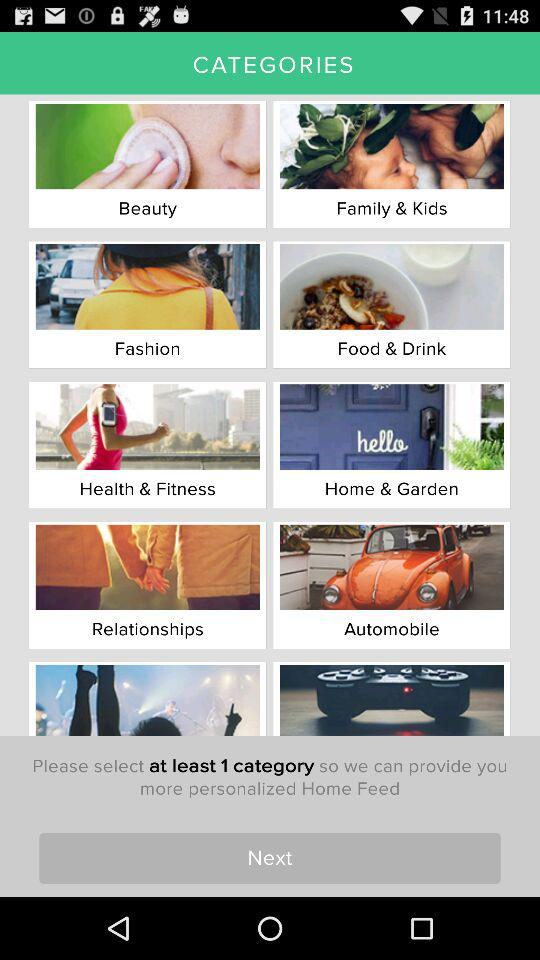How much total selection from the categories needs to be done? The total selection needs to be at least one category. 